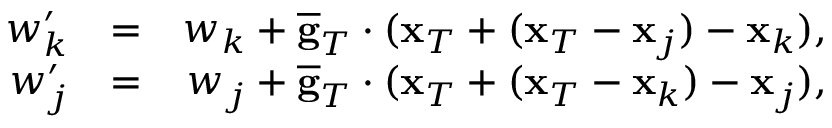Convert formula to latex. <formula><loc_0><loc_0><loc_500><loc_500>\begin{array} { r l r } { w _ { k } ^ { \prime } } & { = } & { w _ { k } + \overline { g } _ { T } \cdot ( { x } _ { T } + ( { x } _ { T } - { x } _ { j } ) - { x } _ { k } ) , } \\ { w _ { j } ^ { \prime } } & { = } & { w _ { j } + \overline { g } _ { T } \cdot ( { x } _ { T } + ( { x } _ { T } - { x } _ { k } ) - { x } _ { j } ) , } \end{array}</formula> 